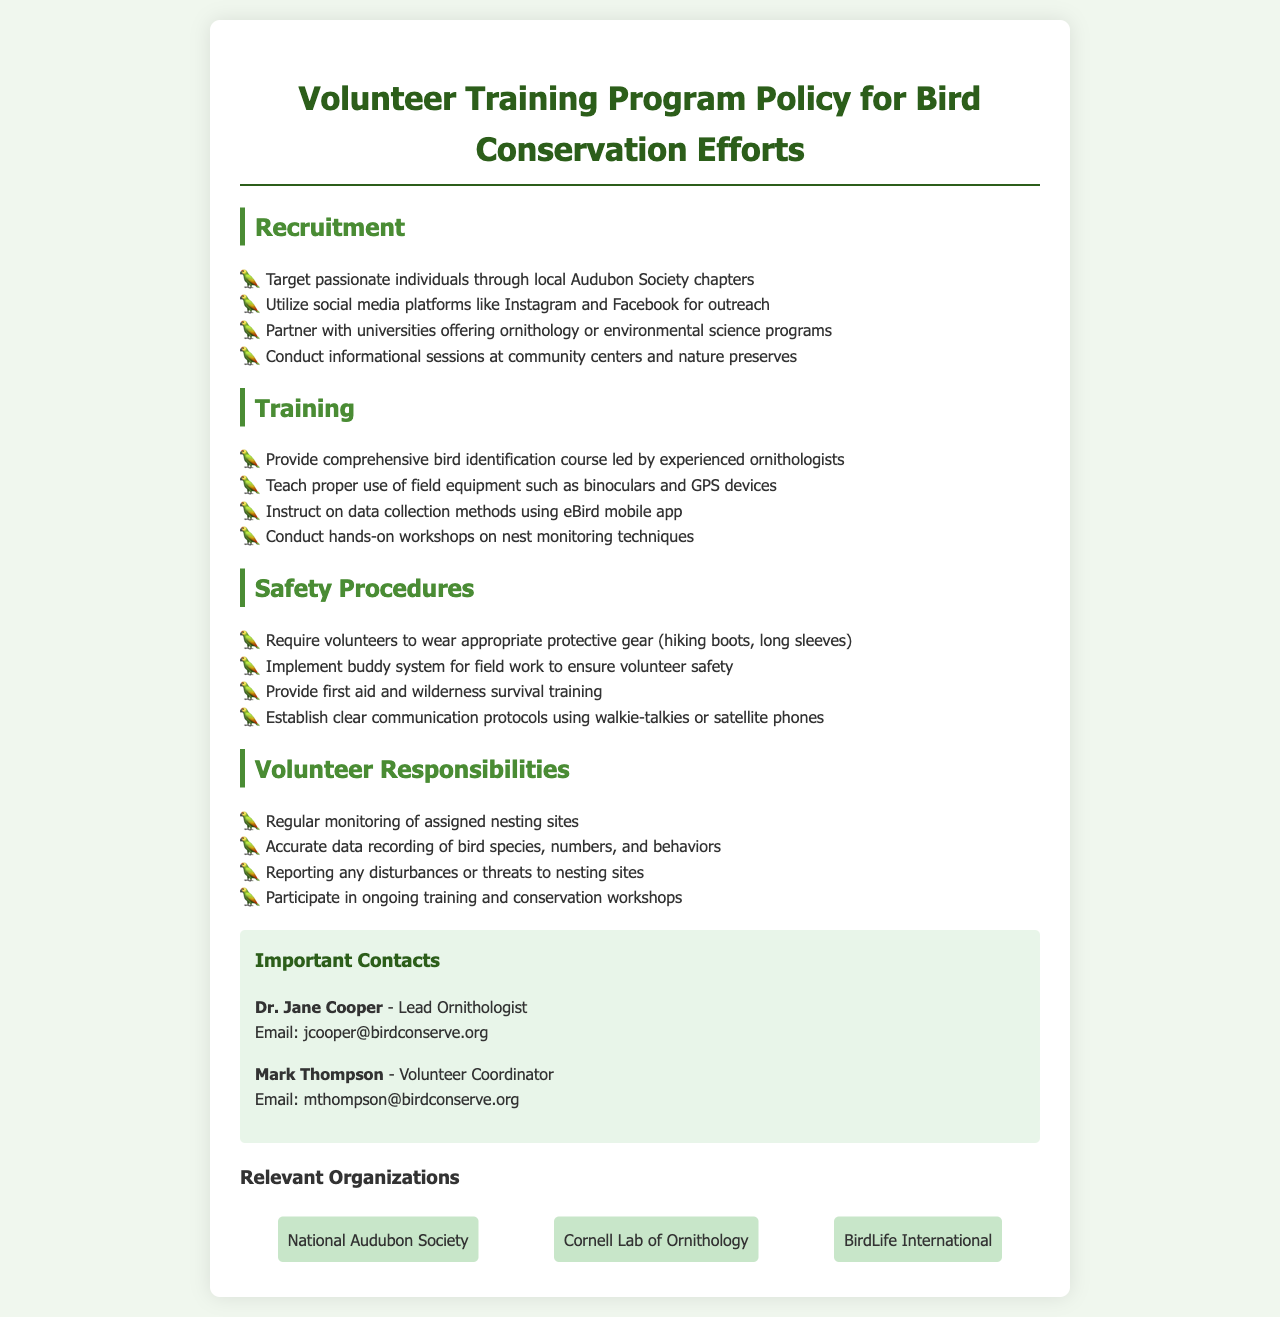What is the title of the document? The title of the document is stated at the top as "Volunteer Training Program Policy for Bird Conservation Efforts."
Answer: Volunteer Training Program Policy for Bird Conservation Efforts Who is the Lead Ornithologist mentioned in the document? The document provides the name of the Lead Ornithologist, which is included in the contact information section.
Answer: Dr. Jane Cooper What is one of the methods used for recruiting volunteers? The document lists several methods for recruitment, including outreach methods mentioned in the recruitment section.
Answer: Social media platforms What item must volunteers wear as part of safety procedures? The safety procedures specify what volunteers are required to wear when participating in field work.
Answer: Protective gear What type of training is included in the training section? The training section highlights types of training that volunteers will undergo, such as specific courses or workshops.
Answer: Bird identification course Why is the buddy system implemented? The buddy system is mentioned to highlight its purpose regarding volunteer safety in the field work section.
Answer: To ensure volunteer safety What should volunteers report according to their responsibilities? The responsibilities section specifies what volunteers need to report during their monitoring activities.
Answer: Disturbances or threats How many organizations are listed under relevant organizations? The relevant organizations section states the number of organizations that are mentioned as part of the policy.
Answer: Three 